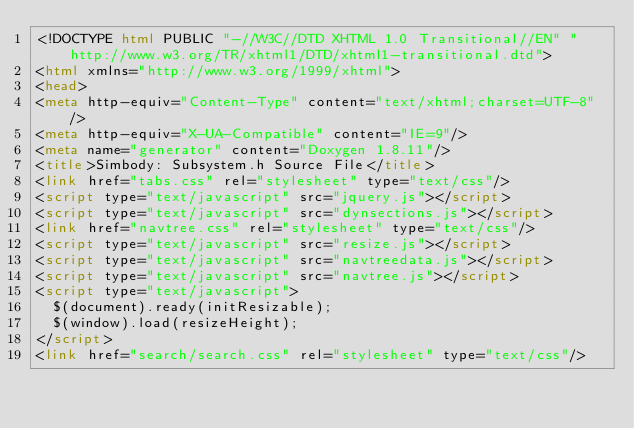Convert code to text. <code><loc_0><loc_0><loc_500><loc_500><_HTML_><!DOCTYPE html PUBLIC "-//W3C//DTD XHTML 1.0 Transitional//EN" "http://www.w3.org/TR/xhtml1/DTD/xhtml1-transitional.dtd">
<html xmlns="http://www.w3.org/1999/xhtml">
<head>
<meta http-equiv="Content-Type" content="text/xhtml;charset=UTF-8"/>
<meta http-equiv="X-UA-Compatible" content="IE=9"/>
<meta name="generator" content="Doxygen 1.8.11"/>
<title>Simbody: Subsystem.h Source File</title>
<link href="tabs.css" rel="stylesheet" type="text/css"/>
<script type="text/javascript" src="jquery.js"></script>
<script type="text/javascript" src="dynsections.js"></script>
<link href="navtree.css" rel="stylesheet" type="text/css"/>
<script type="text/javascript" src="resize.js"></script>
<script type="text/javascript" src="navtreedata.js"></script>
<script type="text/javascript" src="navtree.js"></script>
<script type="text/javascript">
  $(document).ready(initResizable);
  $(window).load(resizeHeight);
</script>
<link href="search/search.css" rel="stylesheet" type="text/css"/></code> 